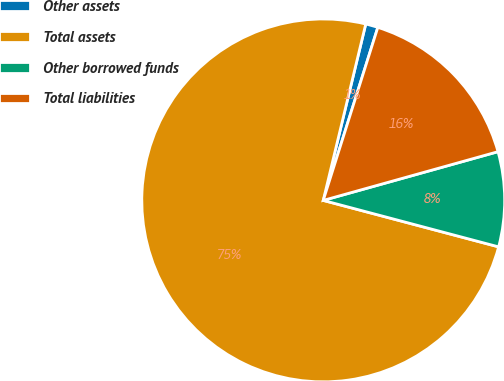Convert chart. <chart><loc_0><loc_0><loc_500><loc_500><pie_chart><fcel>Other assets<fcel>Total assets<fcel>Other borrowed funds<fcel>Total liabilities<nl><fcel>1.1%<fcel>74.65%<fcel>8.45%<fcel>15.81%<nl></chart> 